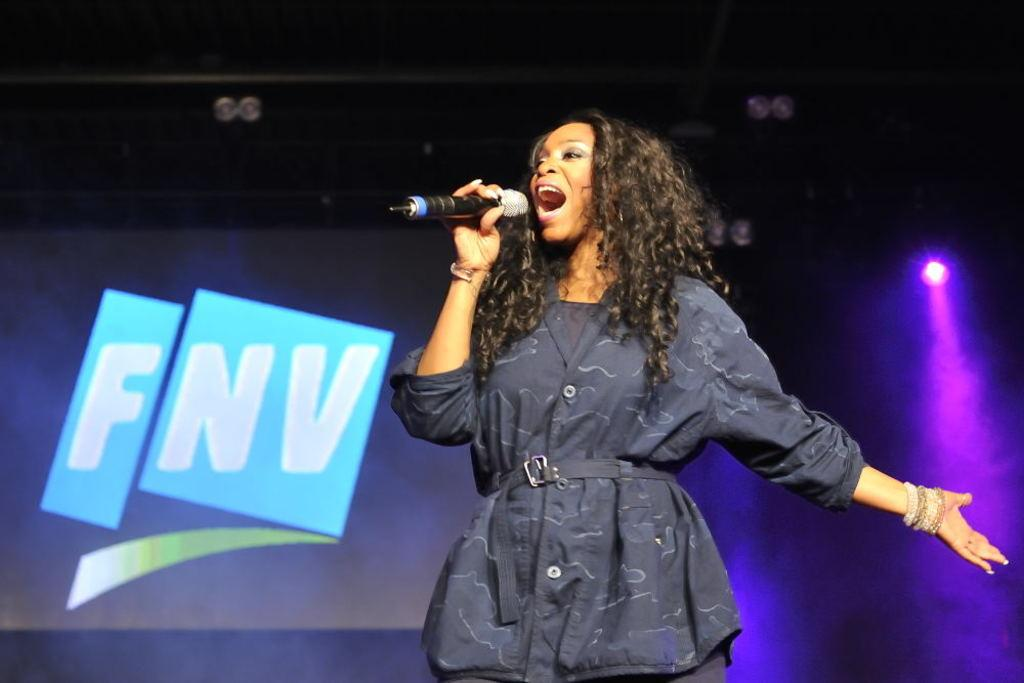Who is the main subject in the image? There is a woman in the image. Where is the woman positioned in the image? The woman is standing in the middle of the image. What is the woman holding in the image? The woman is holding a microphone. What is the woman doing in the image? The woman is singing. What can be seen behind the woman in the image? There is a screen and light behind the woman. What type of whip is the woman using to perform in the image? There is no whip present in the image; the woman is holding a microphone and singing. What attraction is the woman a part of in the image? The image does not provide information about any specific attraction; it simply shows a woman singing with a microphone. 